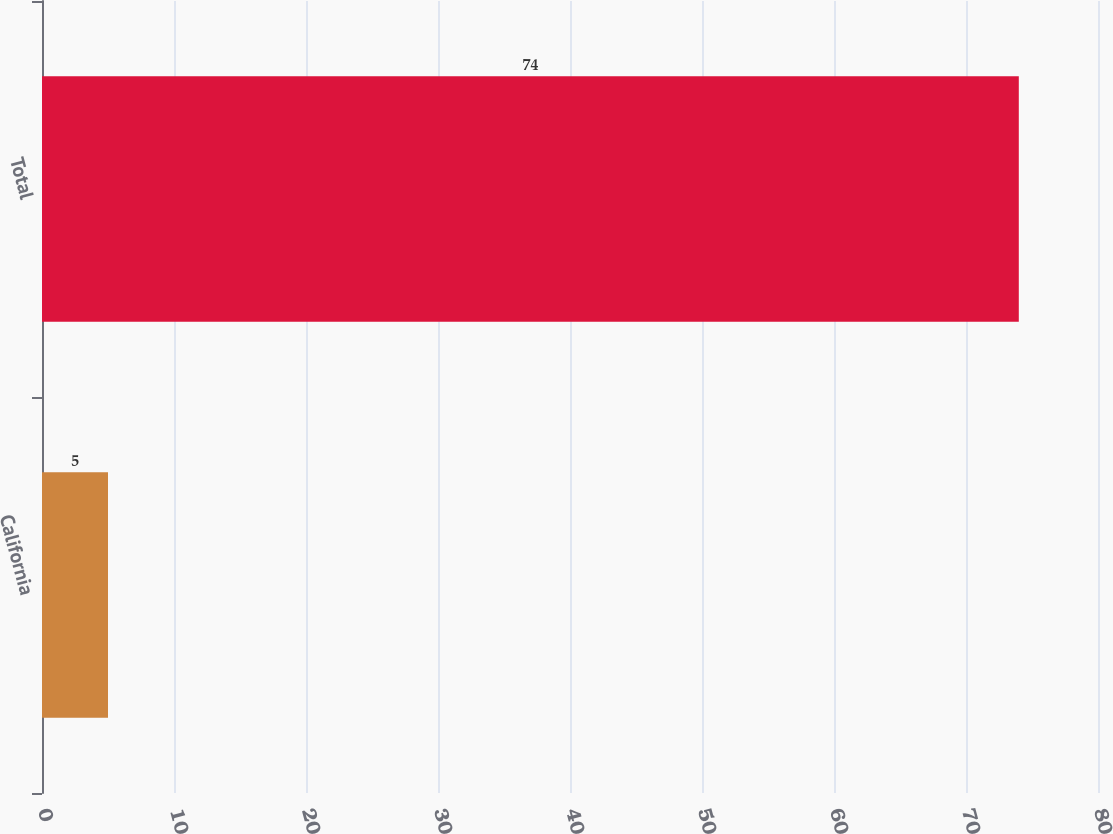<chart> <loc_0><loc_0><loc_500><loc_500><bar_chart><fcel>California<fcel>Total<nl><fcel>5<fcel>74<nl></chart> 